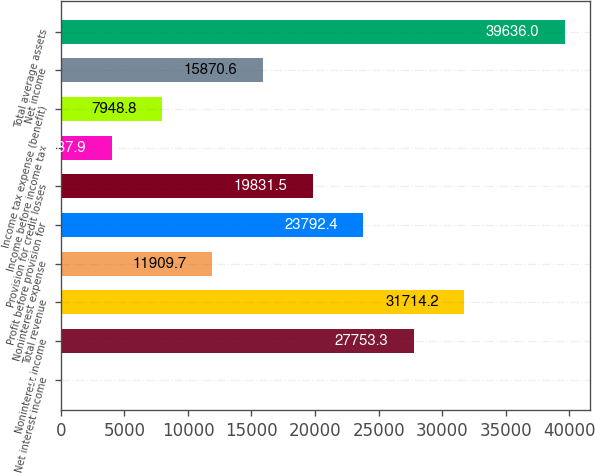Convert chart. <chart><loc_0><loc_0><loc_500><loc_500><bar_chart><fcel>Net interest income<fcel>Noninterest income<fcel>Total revenue<fcel>Noninterest expense<fcel>Profit before provision for<fcel>Provision for credit losses<fcel>Income before income tax<fcel>Income tax expense (benefit)<fcel>Net income<fcel>Total average assets<nl><fcel>27<fcel>27753.3<fcel>31714.2<fcel>11909.7<fcel>23792.4<fcel>19831.5<fcel>3987.9<fcel>7948.8<fcel>15870.6<fcel>39636<nl></chart> 